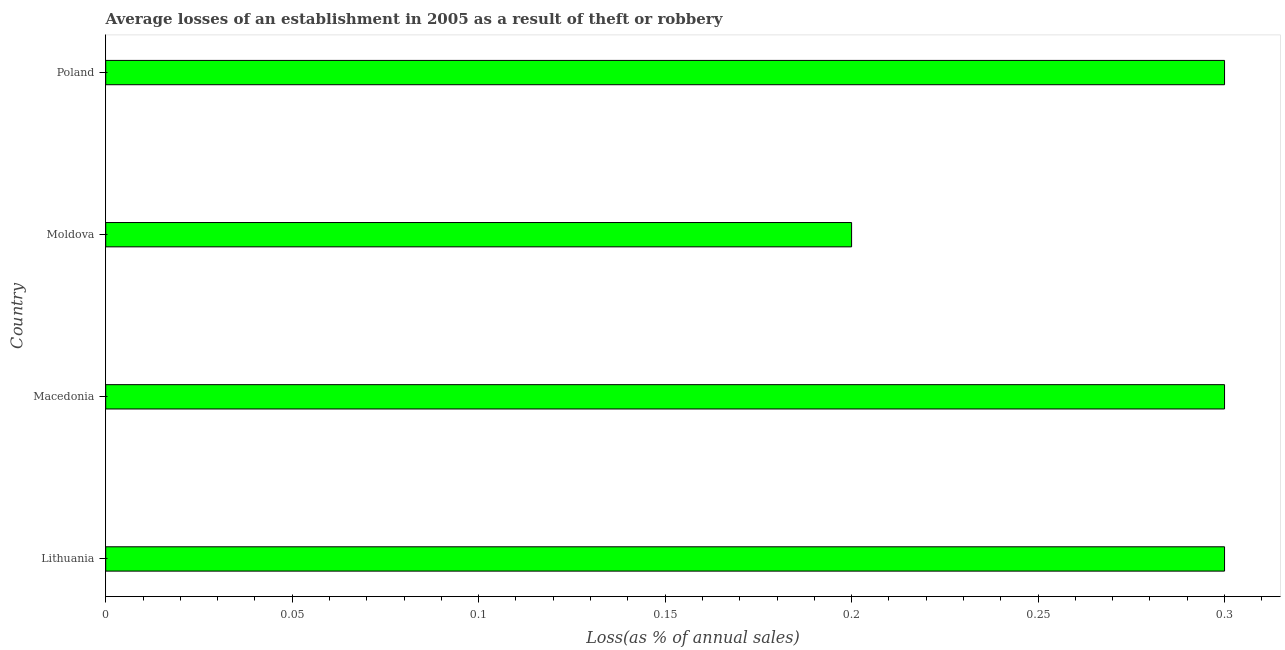Does the graph contain any zero values?
Provide a succinct answer. No. Does the graph contain grids?
Your answer should be compact. No. What is the title of the graph?
Your answer should be compact. Average losses of an establishment in 2005 as a result of theft or robbery. What is the label or title of the X-axis?
Your answer should be compact. Loss(as % of annual sales). What is the label or title of the Y-axis?
Offer a terse response. Country. What is the losses due to theft in Lithuania?
Your answer should be very brief. 0.3. Across all countries, what is the maximum losses due to theft?
Your response must be concise. 0.3. Across all countries, what is the minimum losses due to theft?
Offer a very short reply. 0.2. In which country was the losses due to theft maximum?
Ensure brevity in your answer.  Lithuania. In which country was the losses due to theft minimum?
Make the answer very short. Moldova. What is the average losses due to theft per country?
Make the answer very short. 0.28. What is the ratio of the losses due to theft in Lithuania to that in Moldova?
Keep it short and to the point. 1.5. Is the difference between the losses due to theft in Lithuania and Moldova greater than the difference between any two countries?
Your answer should be compact. Yes. What is the difference between the highest and the lowest losses due to theft?
Your answer should be compact. 0.1. What is the difference between two consecutive major ticks on the X-axis?
Your answer should be compact. 0.05. Are the values on the major ticks of X-axis written in scientific E-notation?
Offer a terse response. No. What is the Loss(as % of annual sales) in Macedonia?
Keep it short and to the point. 0.3. What is the Loss(as % of annual sales) in Moldova?
Your answer should be compact. 0.2. What is the difference between the Loss(as % of annual sales) in Macedonia and Poland?
Offer a terse response. 0. What is the difference between the Loss(as % of annual sales) in Moldova and Poland?
Ensure brevity in your answer.  -0.1. What is the ratio of the Loss(as % of annual sales) in Lithuania to that in Macedonia?
Provide a short and direct response. 1. What is the ratio of the Loss(as % of annual sales) in Lithuania to that in Moldova?
Provide a short and direct response. 1.5. What is the ratio of the Loss(as % of annual sales) in Macedonia to that in Poland?
Your answer should be very brief. 1. What is the ratio of the Loss(as % of annual sales) in Moldova to that in Poland?
Your answer should be compact. 0.67. 